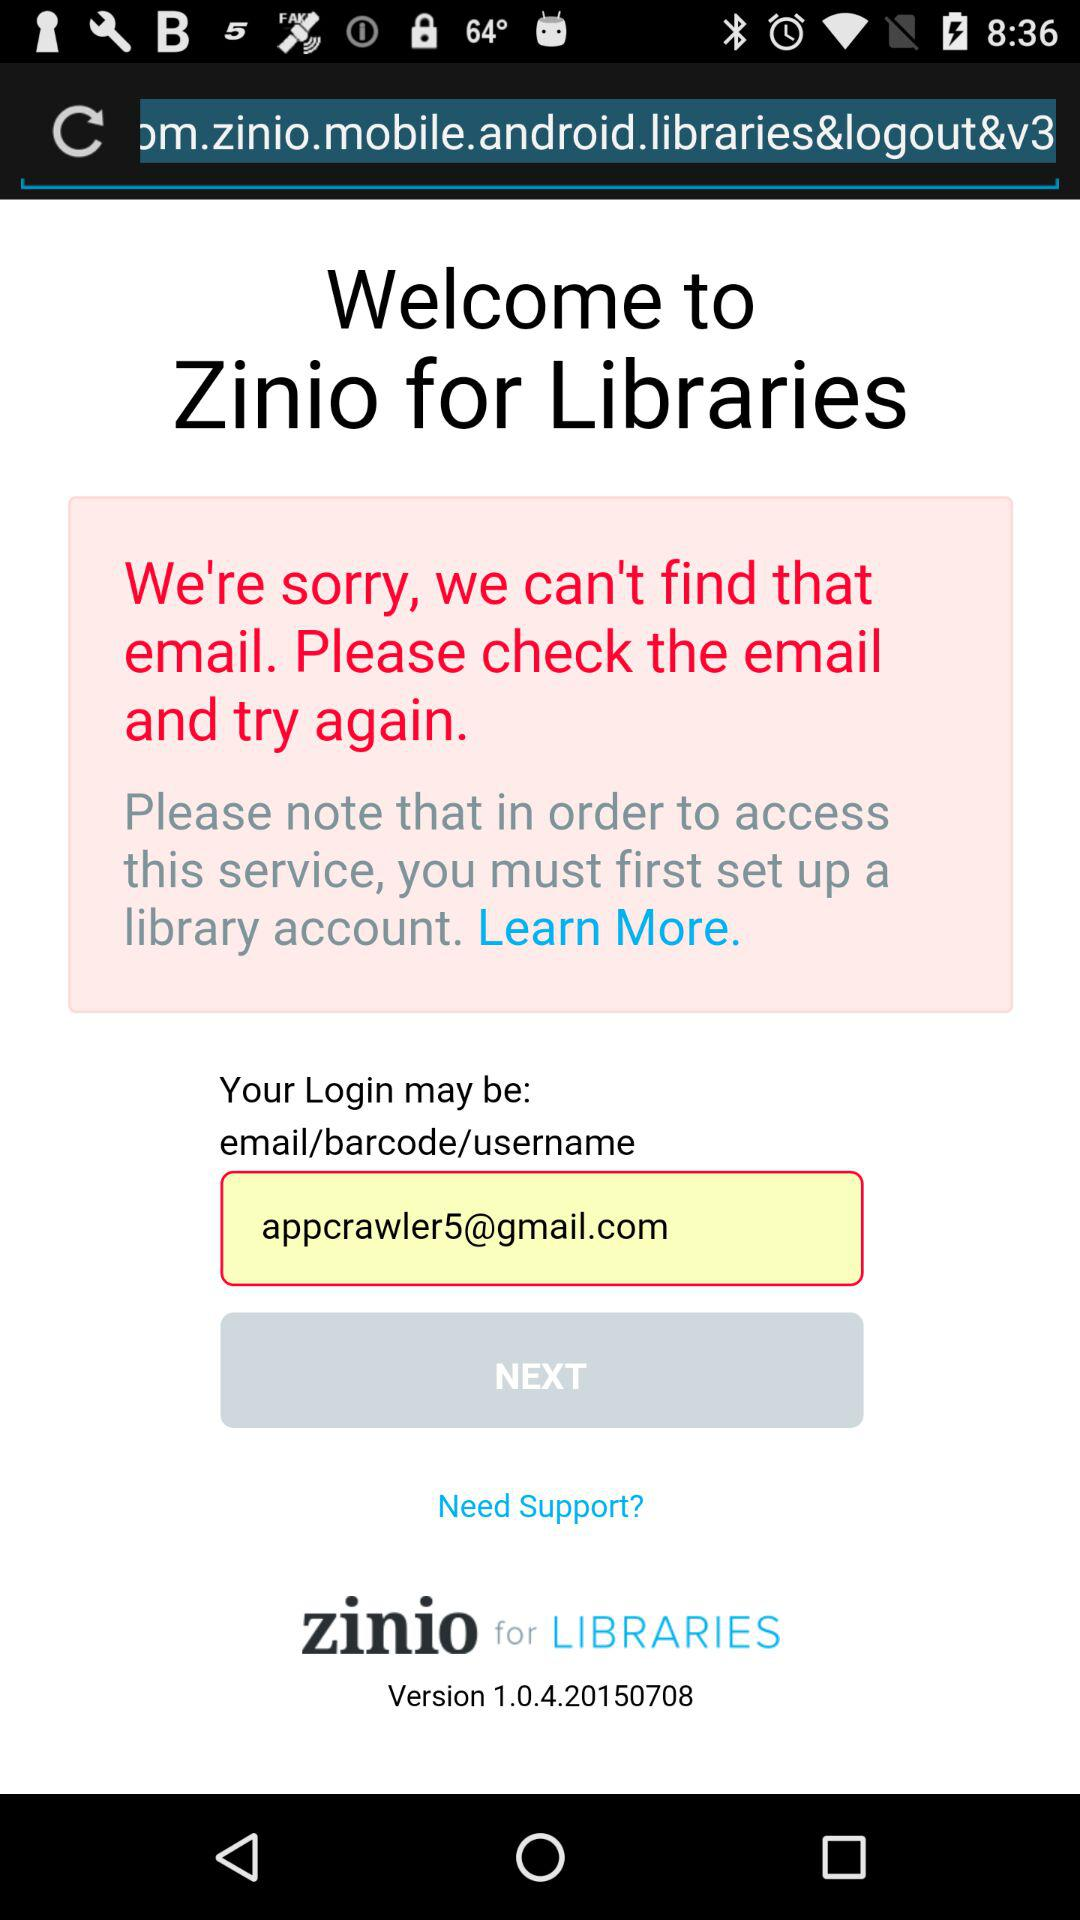What is the version of the application? The version is 1.0.4.20150708. 